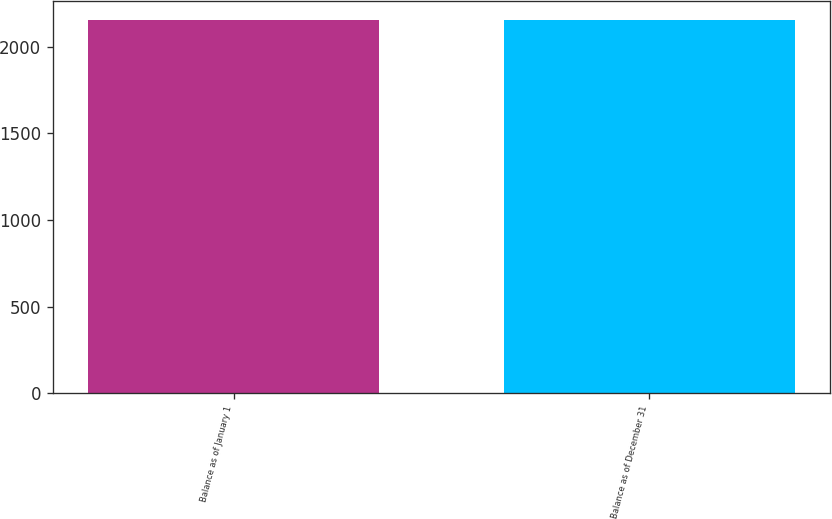Convert chart to OTSL. <chart><loc_0><loc_0><loc_500><loc_500><bar_chart><fcel>Balance as of January 1<fcel>Balance as of December 31<nl><fcel>2156<fcel>2154<nl></chart> 